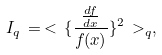<formula> <loc_0><loc_0><loc_500><loc_500>I _ { q } \, = \, < \, \{ \frac { \frac { d f } { d x } } { f ( x ) } \} ^ { 2 } \, > _ { q } ,</formula> 